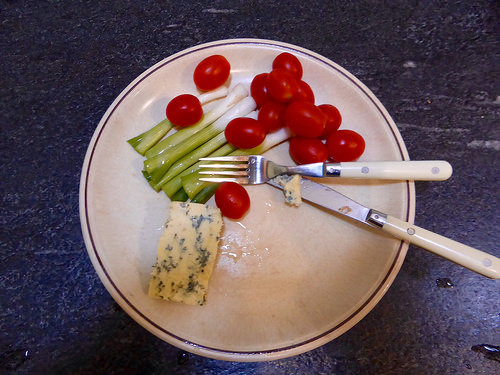<image>
Is the vegetables on the table? Yes. Looking at the image, I can see the vegetables is positioned on top of the table, with the table providing support. 